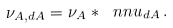Convert formula to latex. <formula><loc_0><loc_0><loc_500><loc_500>\nu _ { A , d A } = \nu _ { A } * \ n n u _ { d A } \, .</formula> 